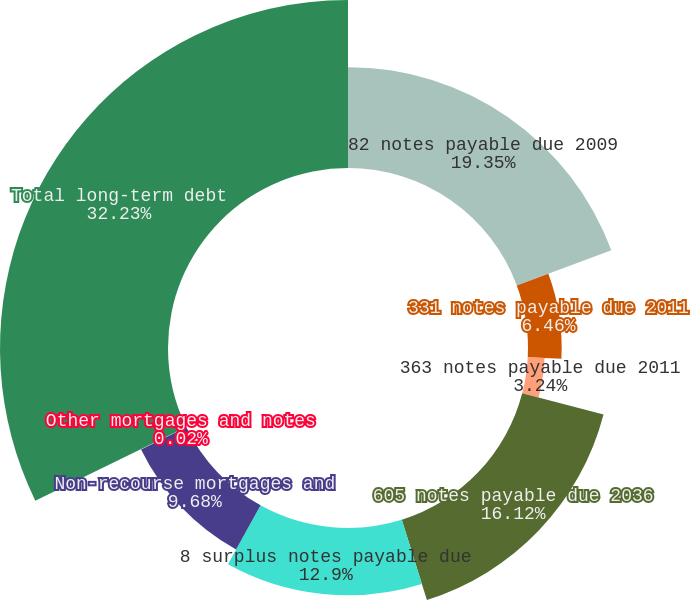Convert chart to OTSL. <chart><loc_0><loc_0><loc_500><loc_500><pie_chart><fcel>82 notes payable due 2009<fcel>331 notes payable due 2011<fcel>363 notes payable due 2011<fcel>605 notes payable due 2036<fcel>8 surplus notes payable due<fcel>Non-recourse mortgages and<fcel>Other mortgages and notes<fcel>Total long-term debt<nl><fcel>19.35%<fcel>6.46%<fcel>3.24%<fcel>16.12%<fcel>12.9%<fcel>9.68%<fcel>0.02%<fcel>32.23%<nl></chart> 